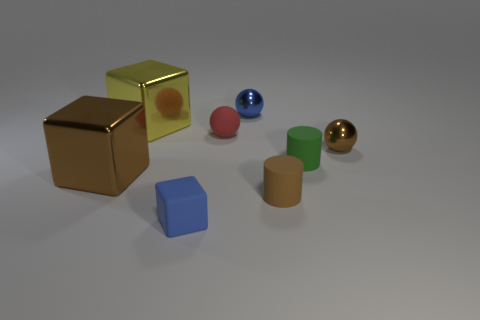The red object that is the same material as the tiny brown cylinder is what shape? sphere 